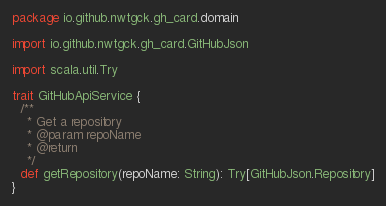Convert code to text. <code><loc_0><loc_0><loc_500><loc_500><_Scala_>package io.github.nwtgck.gh_card.domain

import io.github.nwtgck.gh_card.GitHubJson

import scala.util.Try

trait GitHubApiService {
  /**
    * Get a repository
    * @param repoName
    * @return
    */
  def getRepository(repoName: String): Try[GitHubJson.Repository]
}
</code> 